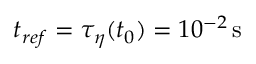Convert formula to latex. <formula><loc_0><loc_0><loc_500><loc_500>t _ { r e f } = \tau _ { \eta } ( t _ { 0 } ) = 1 0 ^ { - 2 } \, s</formula> 